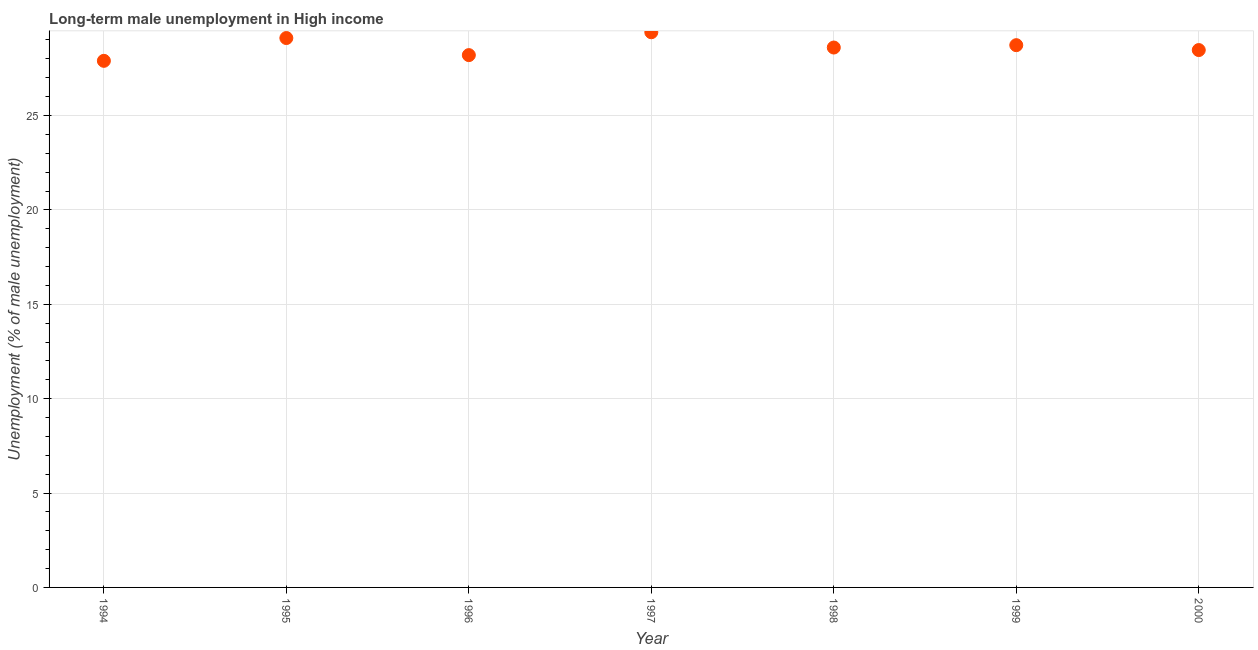What is the long-term male unemployment in 1996?
Make the answer very short. 28.2. Across all years, what is the maximum long-term male unemployment?
Offer a terse response. 29.41. Across all years, what is the minimum long-term male unemployment?
Ensure brevity in your answer.  27.9. In which year was the long-term male unemployment minimum?
Your answer should be compact. 1994. What is the sum of the long-term male unemployment?
Offer a very short reply. 200.41. What is the difference between the long-term male unemployment in 1995 and 1999?
Provide a short and direct response. 0.38. What is the average long-term male unemployment per year?
Offer a terse response. 28.63. What is the median long-term male unemployment?
Keep it short and to the point. 28.6. Do a majority of the years between 1996 and 1998 (inclusive) have long-term male unemployment greater than 5 %?
Keep it short and to the point. Yes. What is the ratio of the long-term male unemployment in 1995 to that in 1996?
Provide a succinct answer. 1.03. Is the long-term male unemployment in 1996 less than that in 2000?
Give a very brief answer. Yes. What is the difference between the highest and the second highest long-term male unemployment?
Keep it short and to the point. 0.31. Is the sum of the long-term male unemployment in 1995 and 1999 greater than the maximum long-term male unemployment across all years?
Offer a very short reply. Yes. What is the difference between the highest and the lowest long-term male unemployment?
Ensure brevity in your answer.  1.51. In how many years, is the long-term male unemployment greater than the average long-term male unemployment taken over all years?
Provide a short and direct response. 3. Does the long-term male unemployment monotonically increase over the years?
Offer a terse response. No. How many dotlines are there?
Keep it short and to the point. 1. How many years are there in the graph?
Your answer should be compact. 7. What is the difference between two consecutive major ticks on the Y-axis?
Provide a short and direct response. 5. Are the values on the major ticks of Y-axis written in scientific E-notation?
Offer a terse response. No. Does the graph contain grids?
Your answer should be compact. Yes. What is the title of the graph?
Make the answer very short. Long-term male unemployment in High income. What is the label or title of the X-axis?
Give a very brief answer. Year. What is the label or title of the Y-axis?
Your answer should be compact. Unemployment (% of male unemployment). What is the Unemployment (% of male unemployment) in 1994?
Provide a short and direct response. 27.9. What is the Unemployment (% of male unemployment) in 1995?
Provide a short and direct response. 29.1. What is the Unemployment (% of male unemployment) in 1996?
Make the answer very short. 28.2. What is the Unemployment (% of male unemployment) in 1997?
Ensure brevity in your answer.  29.41. What is the Unemployment (% of male unemployment) in 1998?
Your answer should be compact. 28.6. What is the Unemployment (% of male unemployment) in 1999?
Your answer should be compact. 28.73. What is the Unemployment (% of male unemployment) in 2000?
Offer a terse response. 28.47. What is the difference between the Unemployment (% of male unemployment) in 1994 and 1995?
Your answer should be very brief. -1.21. What is the difference between the Unemployment (% of male unemployment) in 1994 and 1996?
Ensure brevity in your answer.  -0.3. What is the difference between the Unemployment (% of male unemployment) in 1994 and 1997?
Your answer should be very brief. -1.51. What is the difference between the Unemployment (% of male unemployment) in 1994 and 1998?
Your response must be concise. -0.7. What is the difference between the Unemployment (% of male unemployment) in 1994 and 1999?
Give a very brief answer. -0.83. What is the difference between the Unemployment (% of male unemployment) in 1994 and 2000?
Your answer should be compact. -0.57. What is the difference between the Unemployment (% of male unemployment) in 1995 and 1996?
Keep it short and to the point. 0.9. What is the difference between the Unemployment (% of male unemployment) in 1995 and 1997?
Give a very brief answer. -0.31. What is the difference between the Unemployment (% of male unemployment) in 1995 and 1998?
Provide a short and direct response. 0.5. What is the difference between the Unemployment (% of male unemployment) in 1995 and 1999?
Your response must be concise. 0.38. What is the difference between the Unemployment (% of male unemployment) in 1995 and 2000?
Your response must be concise. 0.64. What is the difference between the Unemployment (% of male unemployment) in 1996 and 1997?
Provide a short and direct response. -1.21. What is the difference between the Unemployment (% of male unemployment) in 1996 and 1998?
Your answer should be compact. -0.4. What is the difference between the Unemployment (% of male unemployment) in 1996 and 1999?
Offer a very short reply. -0.53. What is the difference between the Unemployment (% of male unemployment) in 1996 and 2000?
Keep it short and to the point. -0.27. What is the difference between the Unemployment (% of male unemployment) in 1997 and 1998?
Your answer should be compact. 0.81. What is the difference between the Unemployment (% of male unemployment) in 1997 and 1999?
Your answer should be very brief. 0.68. What is the difference between the Unemployment (% of male unemployment) in 1997 and 2000?
Your response must be concise. 0.94. What is the difference between the Unemployment (% of male unemployment) in 1998 and 1999?
Your answer should be compact. -0.13. What is the difference between the Unemployment (% of male unemployment) in 1998 and 2000?
Give a very brief answer. 0.13. What is the difference between the Unemployment (% of male unemployment) in 1999 and 2000?
Your response must be concise. 0.26. What is the ratio of the Unemployment (% of male unemployment) in 1994 to that in 1995?
Your response must be concise. 0.96. What is the ratio of the Unemployment (% of male unemployment) in 1994 to that in 1996?
Offer a terse response. 0.99. What is the ratio of the Unemployment (% of male unemployment) in 1994 to that in 1997?
Your answer should be compact. 0.95. What is the ratio of the Unemployment (% of male unemployment) in 1994 to that in 1998?
Keep it short and to the point. 0.97. What is the ratio of the Unemployment (% of male unemployment) in 1995 to that in 1996?
Keep it short and to the point. 1.03. What is the ratio of the Unemployment (% of male unemployment) in 1995 to that in 1997?
Offer a terse response. 0.99. What is the ratio of the Unemployment (% of male unemployment) in 1995 to that in 1998?
Offer a terse response. 1.02. What is the ratio of the Unemployment (% of male unemployment) in 1995 to that in 2000?
Your answer should be compact. 1.02. What is the ratio of the Unemployment (% of male unemployment) in 1996 to that in 1997?
Provide a short and direct response. 0.96. What is the ratio of the Unemployment (% of male unemployment) in 1996 to that in 2000?
Provide a short and direct response. 0.99. What is the ratio of the Unemployment (% of male unemployment) in 1997 to that in 1998?
Ensure brevity in your answer.  1.03. What is the ratio of the Unemployment (% of male unemployment) in 1997 to that in 1999?
Ensure brevity in your answer.  1.02. What is the ratio of the Unemployment (% of male unemployment) in 1997 to that in 2000?
Keep it short and to the point. 1.03. What is the ratio of the Unemployment (% of male unemployment) in 1998 to that in 1999?
Provide a succinct answer. 1. What is the ratio of the Unemployment (% of male unemployment) in 1998 to that in 2000?
Offer a very short reply. 1. 